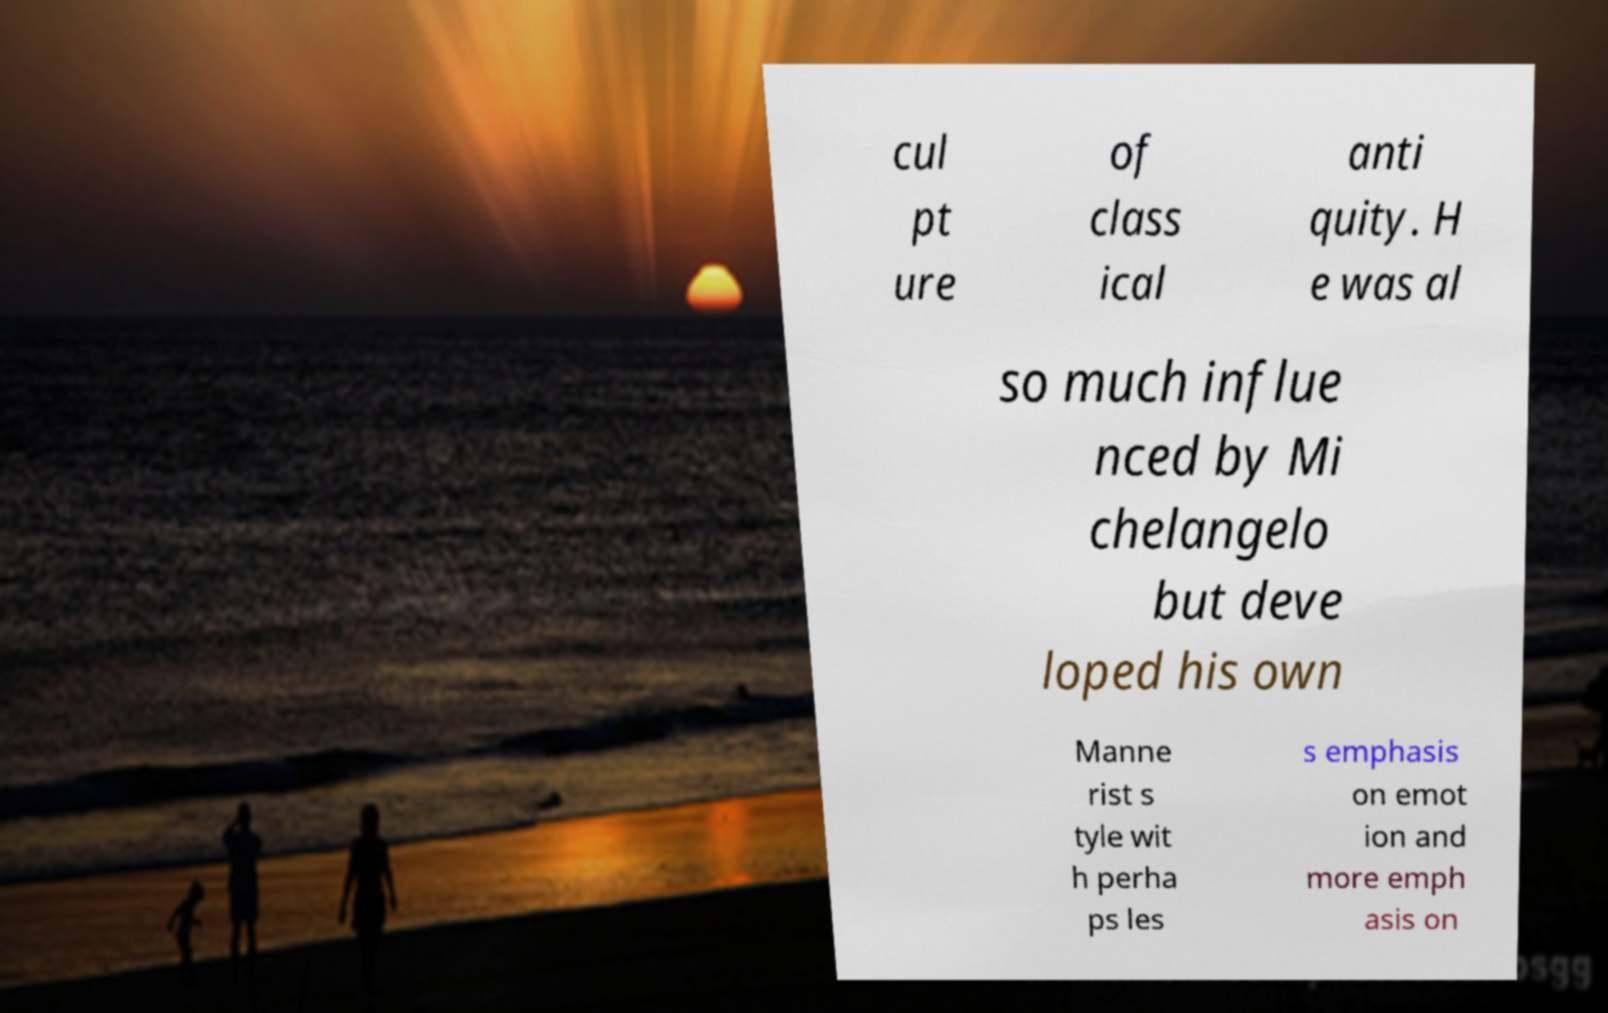Could you assist in decoding the text presented in this image and type it out clearly? cul pt ure of class ical anti quity. H e was al so much influe nced by Mi chelangelo but deve loped his own Manne rist s tyle wit h perha ps les s emphasis on emot ion and more emph asis on 